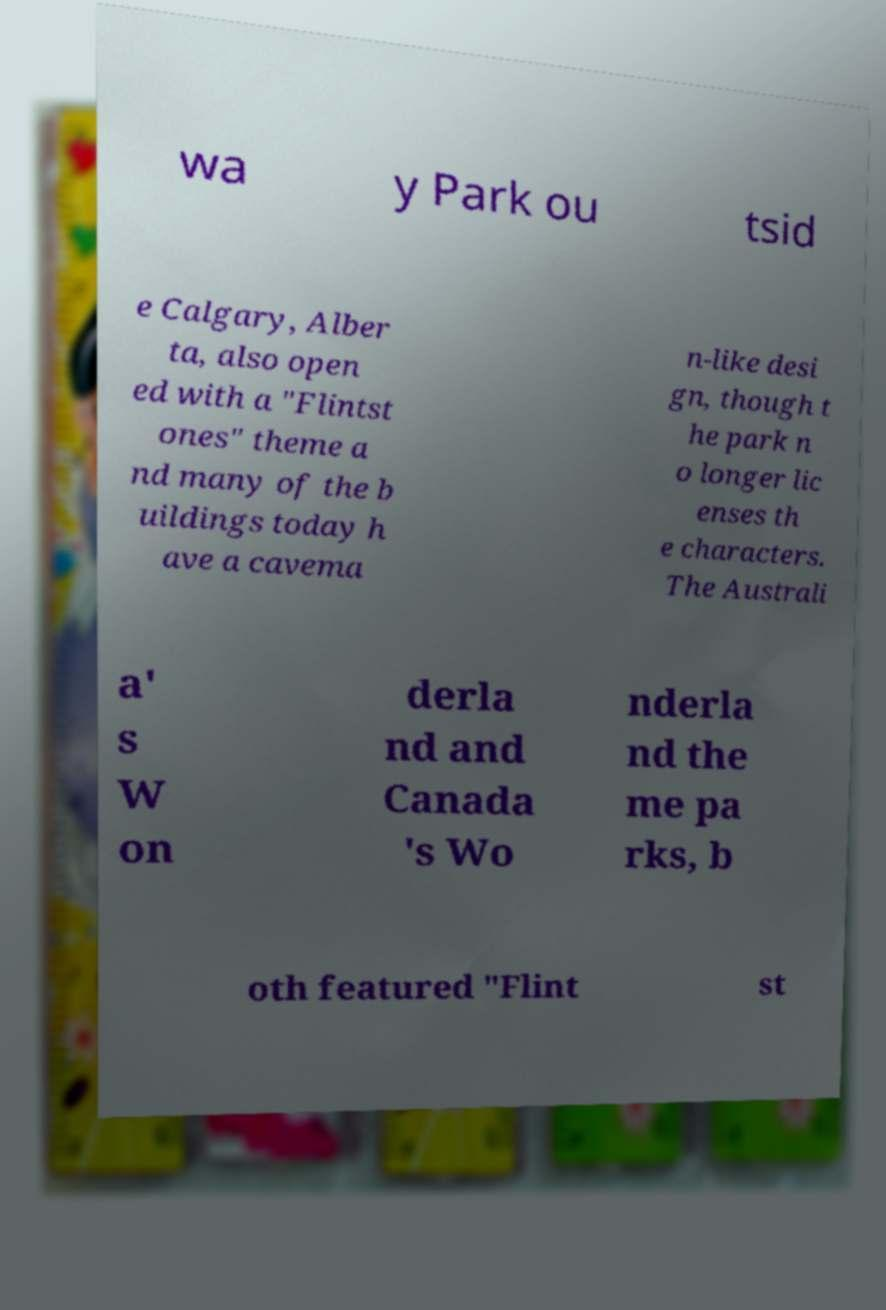Please identify and transcribe the text found in this image. wa y Park ou tsid e Calgary, Alber ta, also open ed with a "Flintst ones" theme a nd many of the b uildings today h ave a cavema n-like desi gn, though t he park n o longer lic enses th e characters. The Australi a' s W on derla nd and Canada 's Wo nderla nd the me pa rks, b oth featured "Flint st 